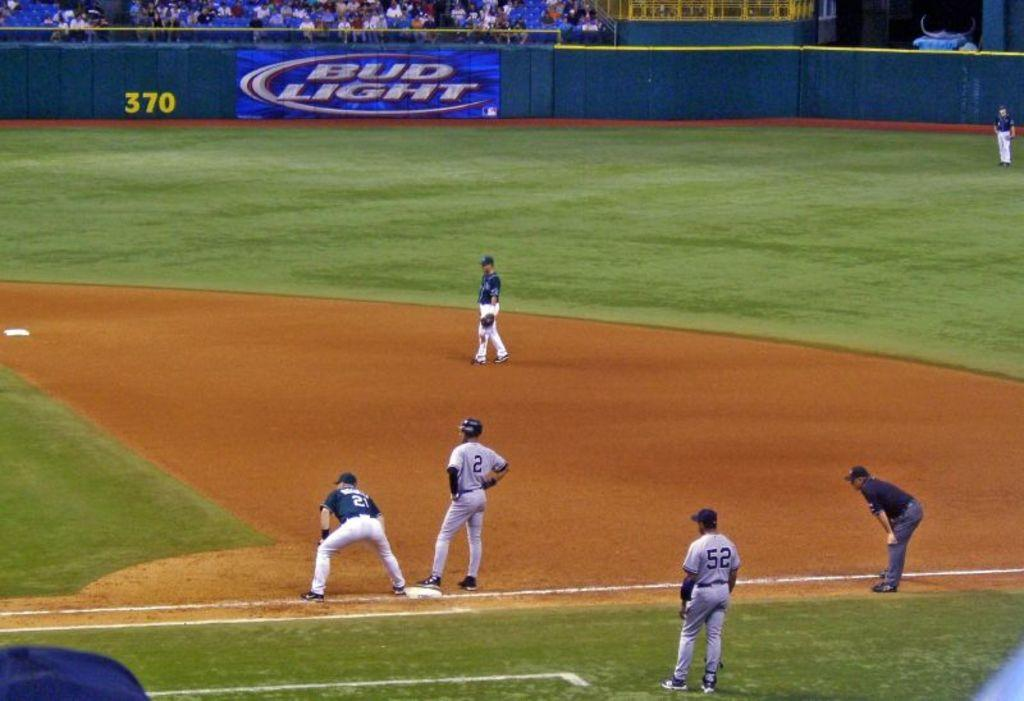Provide a one-sentence caption for the provided image. Bud Light is prominently advertised in the background of this baseball game. 